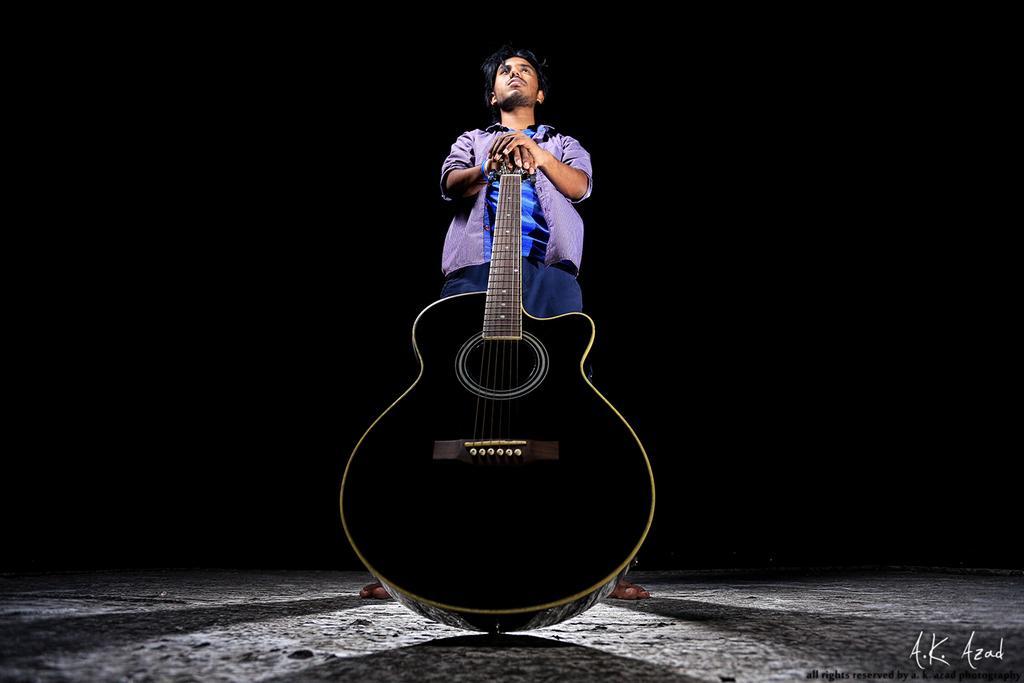How would you summarize this image in a sentence or two? In this image, In the middle there is a man standing and holding a music instrument which is in black color, And in the background there is black color. 